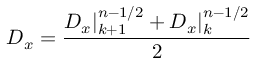<formula> <loc_0><loc_0><loc_500><loc_500>D _ { x } = \frac { D _ { x } | _ { k + 1 } ^ { n - 1 / 2 } + D _ { x } | _ { k } ^ { n - 1 / 2 } } { 2 }</formula> 